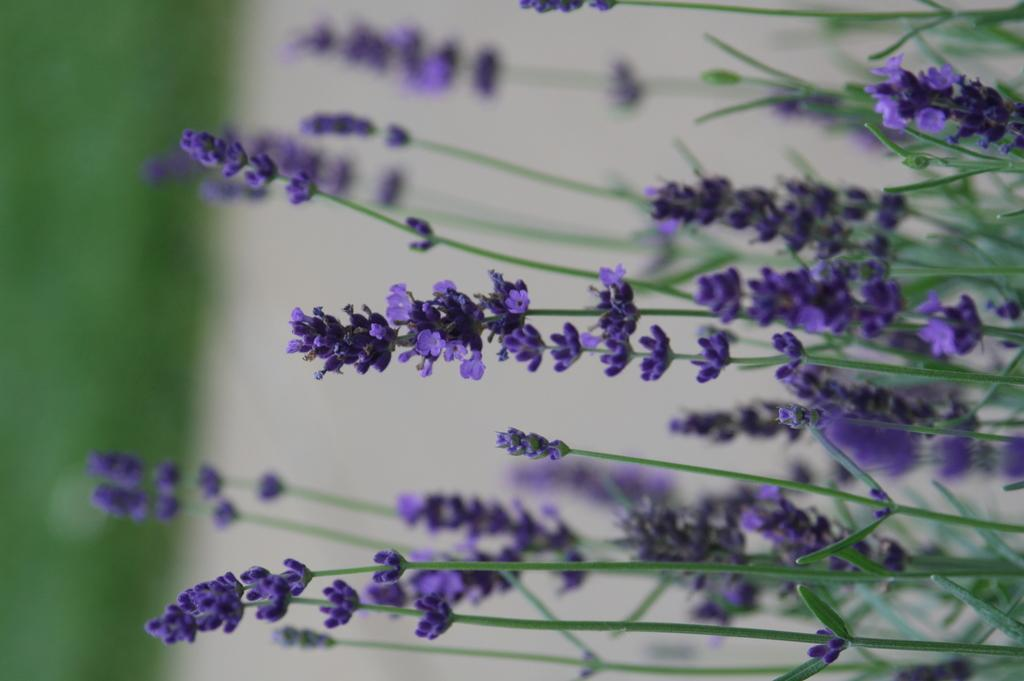What type of plants can be seen in the image? There are flower plants in the image. Can you describe the background of the image? The background area of the image is blurred. What type of power source is visible in the image? There is no power source visible in the image; it only features flower plants and a blurred background. 